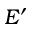Convert formula to latex. <formula><loc_0><loc_0><loc_500><loc_500>E ^ { \prime }</formula> 